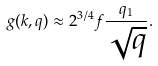<formula> <loc_0><loc_0><loc_500><loc_500>g ( { k } , { q } ) \approx 2 ^ { 3 / 4 } f \frac { q _ { 1 } } { \sqrt { q } } .</formula> 